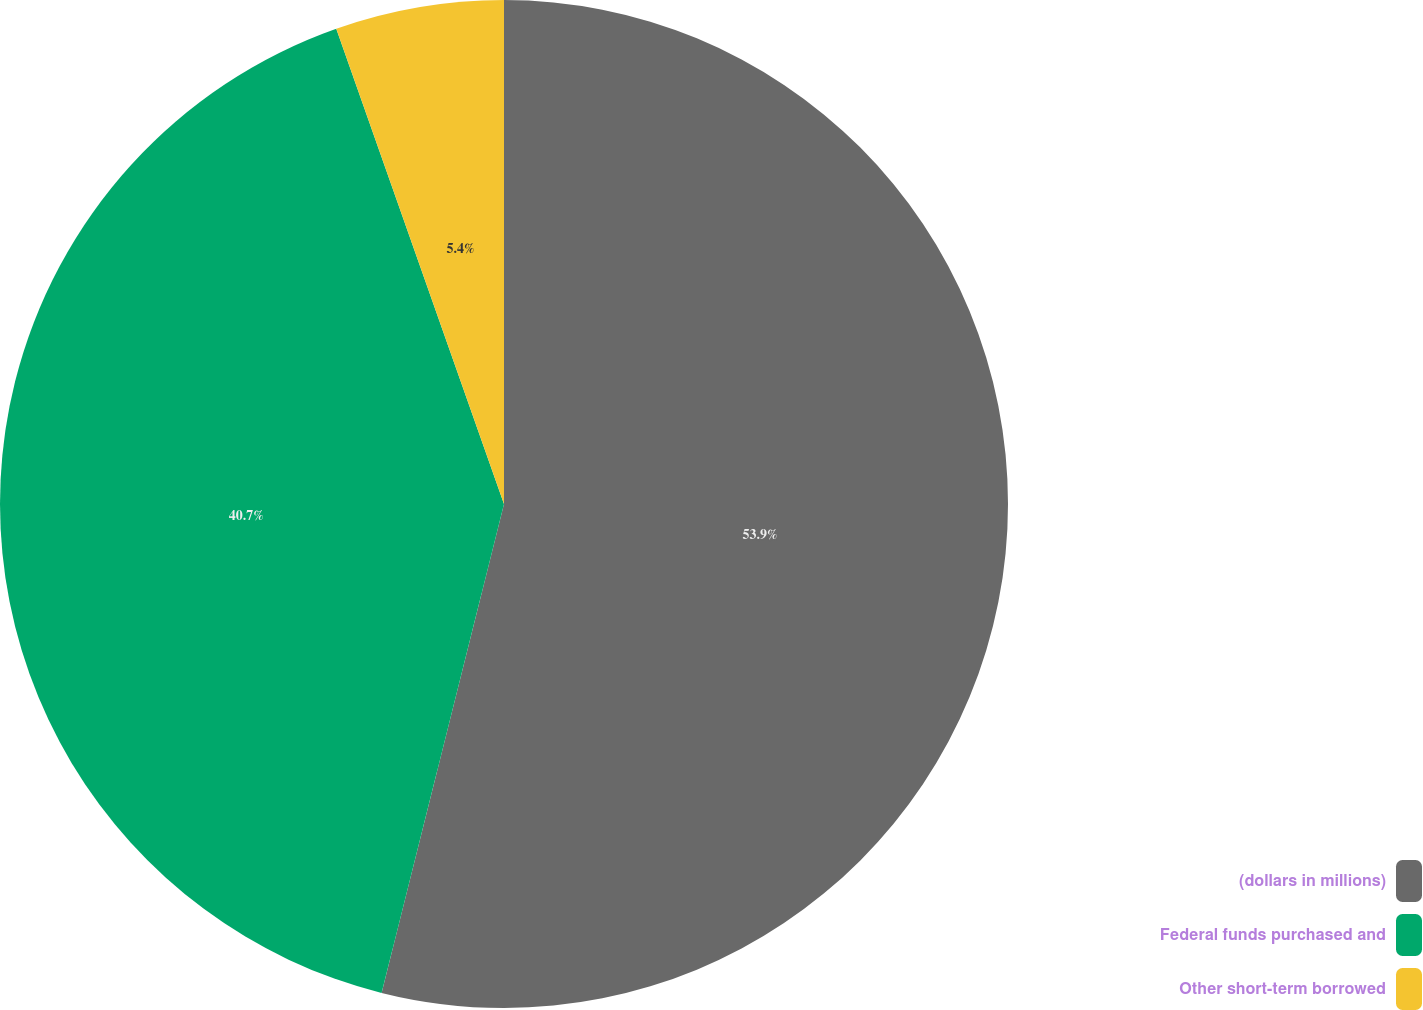<chart> <loc_0><loc_0><loc_500><loc_500><pie_chart><fcel>(dollars in millions)<fcel>Federal funds purchased and<fcel>Other short-term borrowed<nl><fcel>53.91%<fcel>40.7%<fcel>5.4%<nl></chart> 